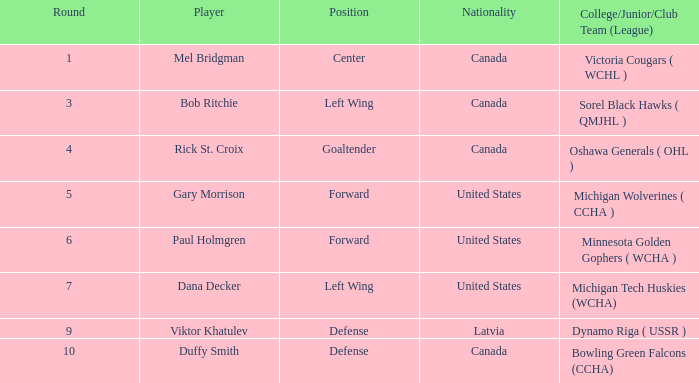What College/Junior/Club Team (League) has 6 as the Round? Minnesota Golden Gophers ( WCHA ). 